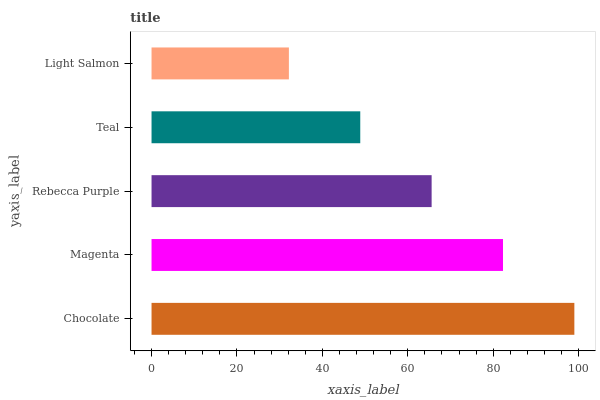Is Light Salmon the minimum?
Answer yes or no. Yes. Is Chocolate the maximum?
Answer yes or no. Yes. Is Magenta the minimum?
Answer yes or no. No. Is Magenta the maximum?
Answer yes or no. No. Is Chocolate greater than Magenta?
Answer yes or no. Yes. Is Magenta less than Chocolate?
Answer yes or no. Yes. Is Magenta greater than Chocolate?
Answer yes or no. No. Is Chocolate less than Magenta?
Answer yes or no. No. Is Rebecca Purple the high median?
Answer yes or no. Yes. Is Rebecca Purple the low median?
Answer yes or no. Yes. Is Magenta the high median?
Answer yes or no. No. Is Teal the low median?
Answer yes or no. No. 